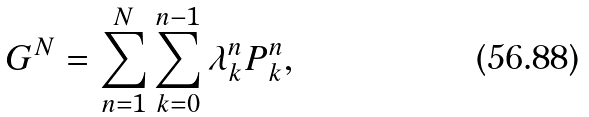<formula> <loc_0><loc_0><loc_500><loc_500>G ^ { N } = \sum _ { n = 1 } ^ { N } \sum _ { k = 0 } ^ { n - 1 } \lambda ^ { n } _ { k } P ^ { n } _ { k } ,</formula> 